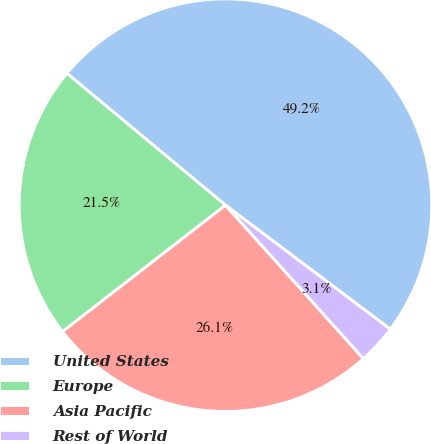<chart> <loc_0><loc_0><loc_500><loc_500><pie_chart><fcel>United States<fcel>Europe<fcel>Asia Pacific<fcel>Rest of World<nl><fcel>49.23%<fcel>21.54%<fcel>26.15%<fcel>3.08%<nl></chart> 